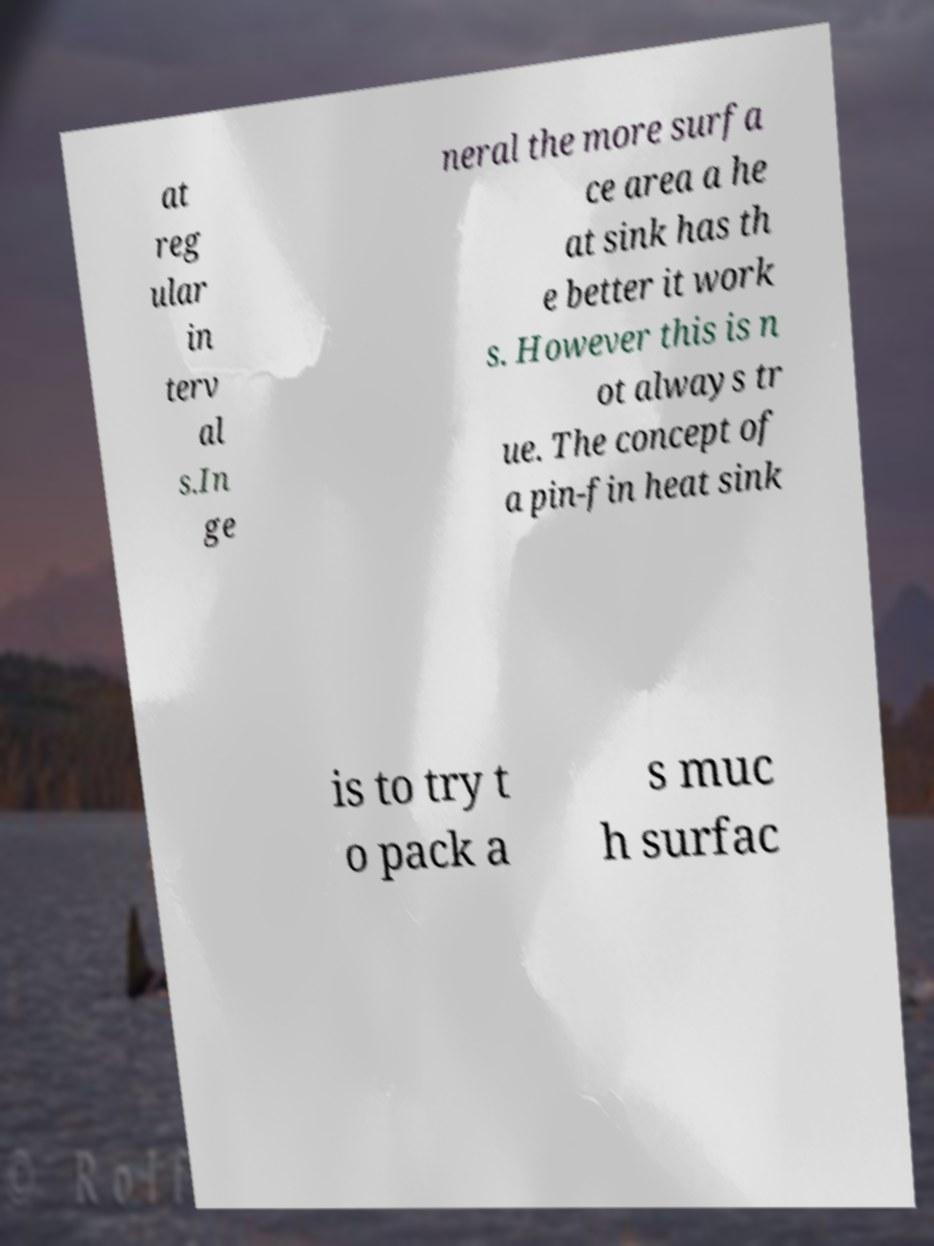There's text embedded in this image that I need extracted. Can you transcribe it verbatim? at reg ular in terv al s.In ge neral the more surfa ce area a he at sink has th e better it work s. However this is n ot always tr ue. The concept of a pin-fin heat sink is to try t o pack a s muc h surfac 